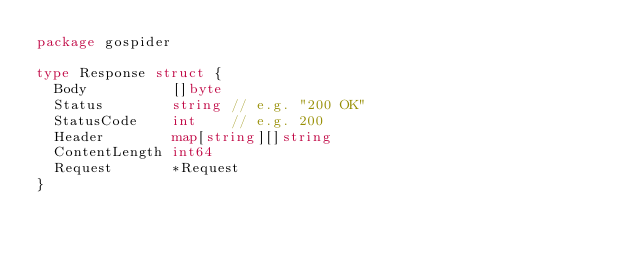<code> <loc_0><loc_0><loc_500><loc_500><_Go_>package gospider

type Response struct {
	Body          []byte
	Status        string // e.g. "200 OK"
	StatusCode    int    // e.g. 200
	Header        map[string][]string
	ContentLength int64
	Request       *Request
}
</code> 